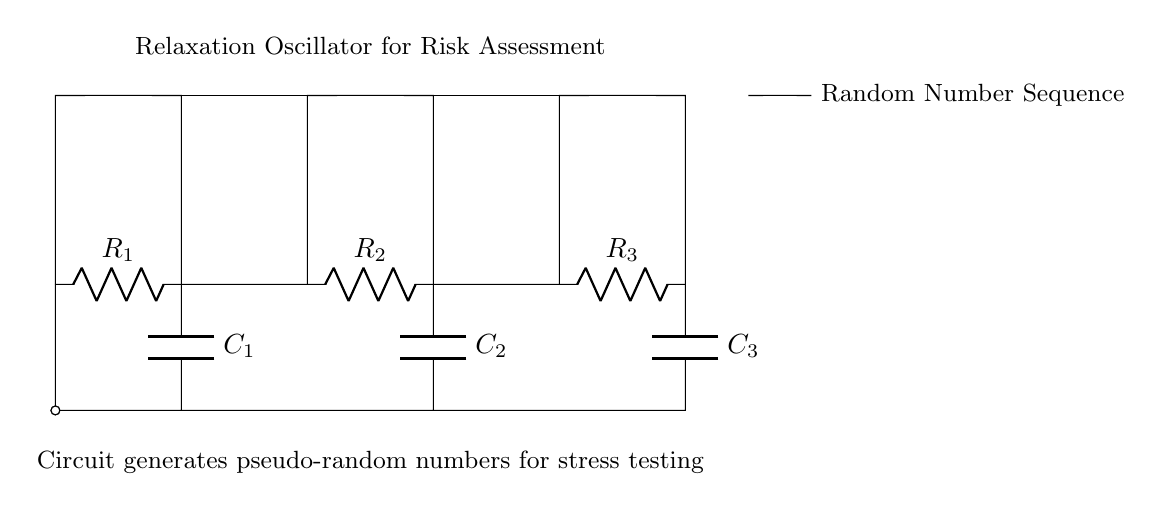What components are present in the oscillator circuit? The circuit diagram shows resistors (R1, R2, R3) and capacitors (C1, C2, C3) connected to Schmitt triggers; these are the main components for generating oscillations.
Answer: Resistors and capacitors What is the purpose of the Schmitt trigger in the circuit? The Schmitt trigger is used to convert the analog voltage levels from the capacitors into digital signals, which helps in creating a stable oscillation by introducing hysteresis.
Answer: To convert analog to digital How many resistors are used in this relaxation oscillator? By counting the labels present in the diagram, there are three resistors labeled R1, R2, and R3.
Answer: Three What is generated at the output of the oscillator circuit? The output of the circuit is indicated to produce a random number sequence for risk assessment, as noted in the diagram.
Answer: Random number sequence How do capacitors contribute to the oscillation in this circuit? Capacitors store and release electrical energy, helping to create the charge-discharge cycle that is essential for generating oscillations in conjunction with the resistors and Schmitt triggers.
Answer: By storing and releasing energy What type of oscillator is represented in this circuit diagram? The presence of the RC components and Schmitt triggers indicates that this is a relaxation oscillator, which is known for producing non-sinusoidal waveforms.
Answer: Relaxation oscillator 